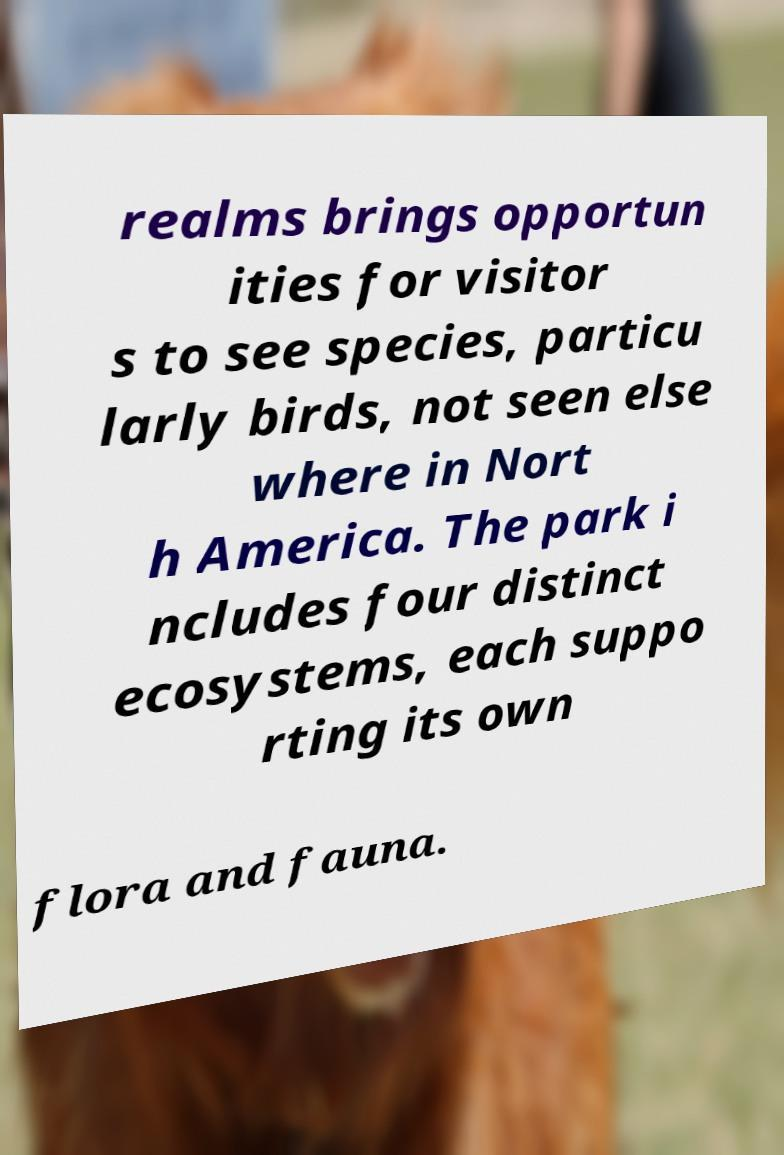Please identify and transcribe the text found in this image. realms brings opportun ities for visitor s to see species, particu larly birds, not seen else where in Nort h America. The park i ncludes four distinct ecosystems, each suppo rting its own flora and fauna. 